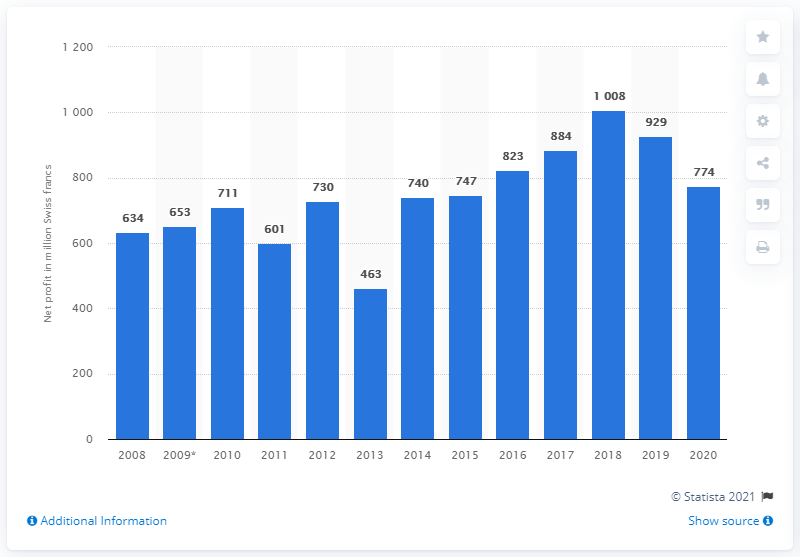Point out several critical features in this image. Schindler's net profit in francs during the fiscal year of 2019 was 774. 